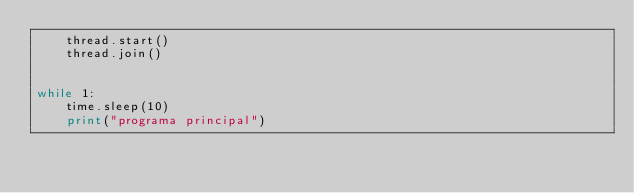Convert code to text. <code><loc_0><loc_0><loc_500><loc_500><_Python_>    thread.start()
    thread.join()


while 1:
    time.sleep(10)
    print("programa principal")</code> 